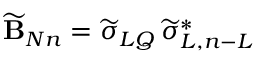Convert formula to latex. <formula><loc_0><loc_0><loc_500><loc_500>\widetilde { B } _ { N n } = \widetilde { \sigma } _ { L Q } \, \widetilde { \sigma } _ { L , n - L } ^ { * }</formula> 